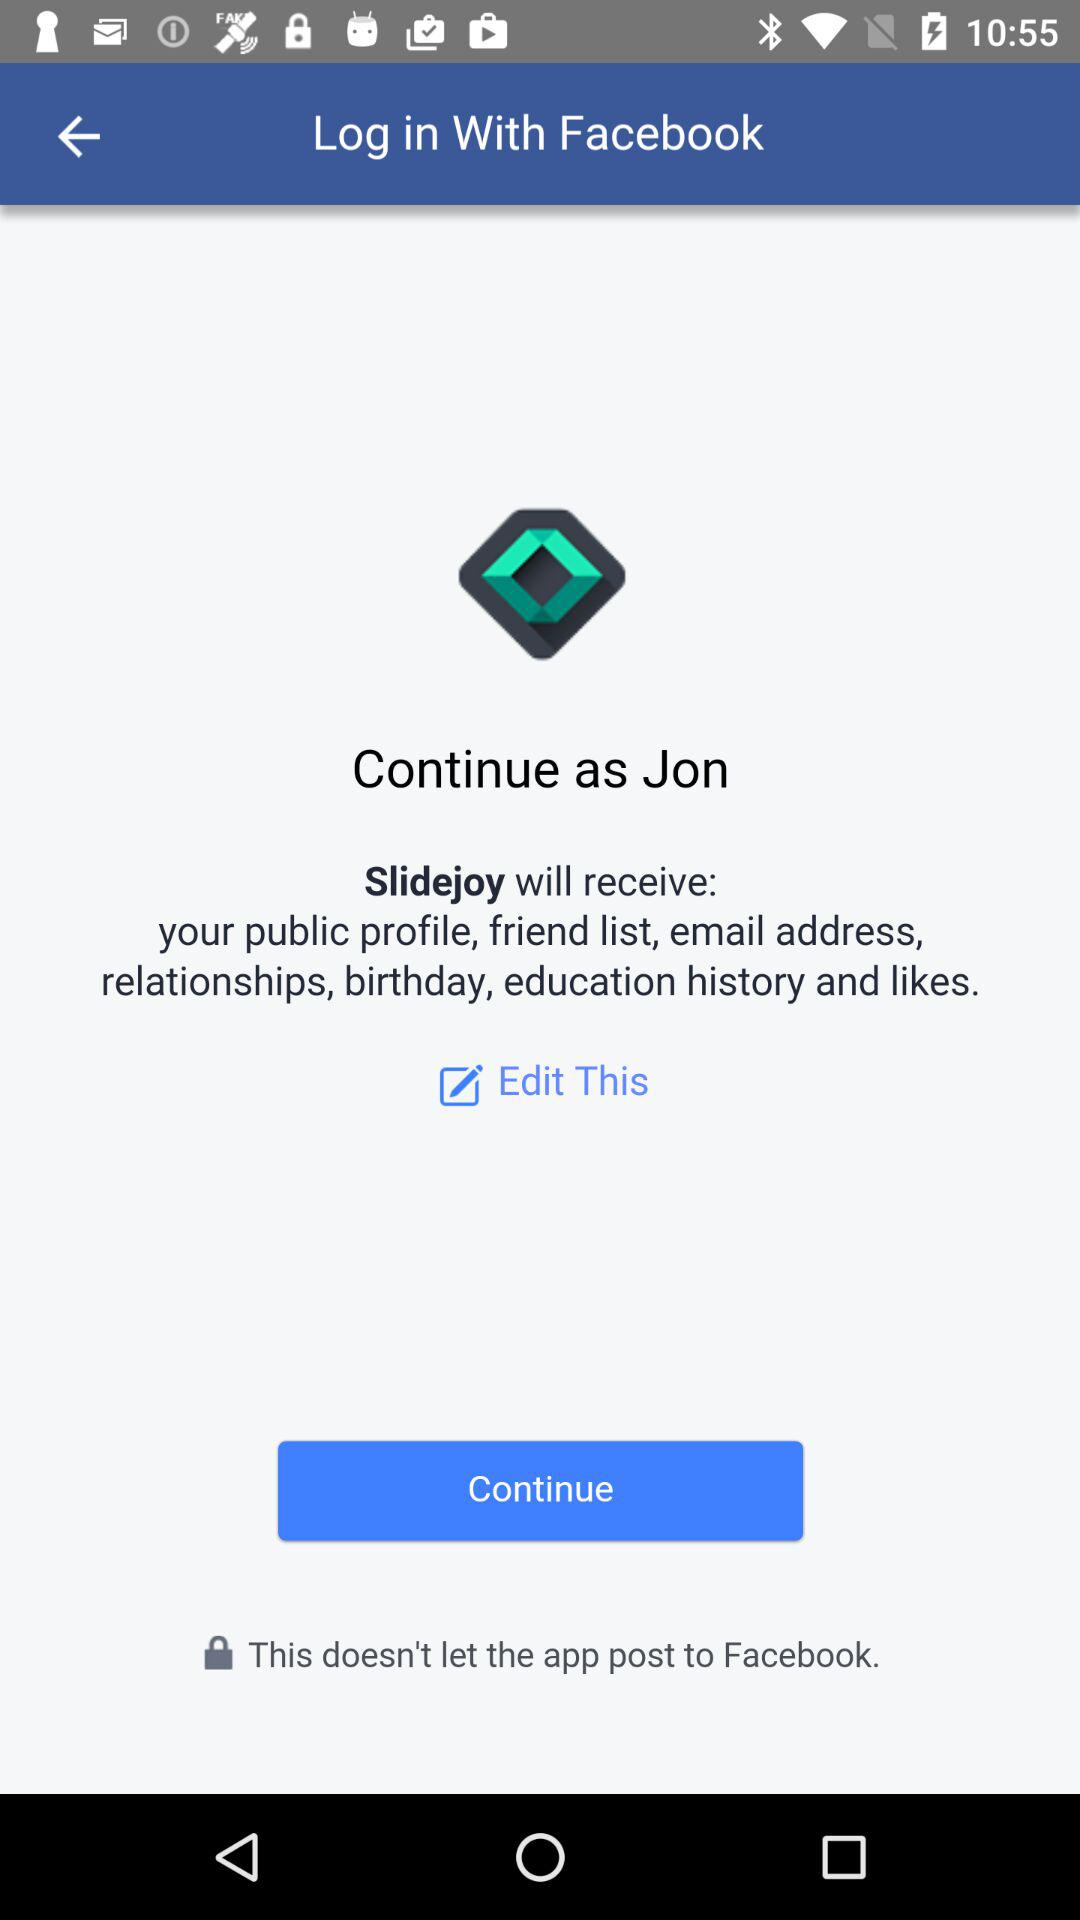With what application is the person logging in? The person is logging in with "Facebook". 